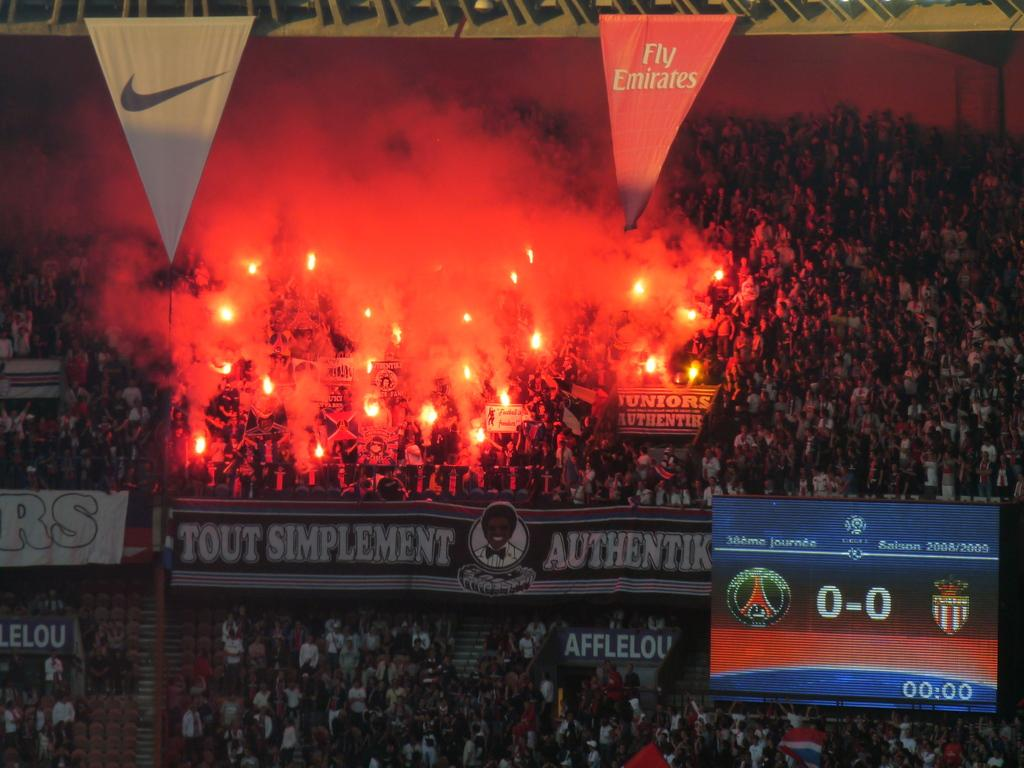<image>
Relay a brief, clear account of the picture shown. Just below a white, triangleA large group of people in the stands, holding flames, above a banner that says Tout Simplement Authentik. 